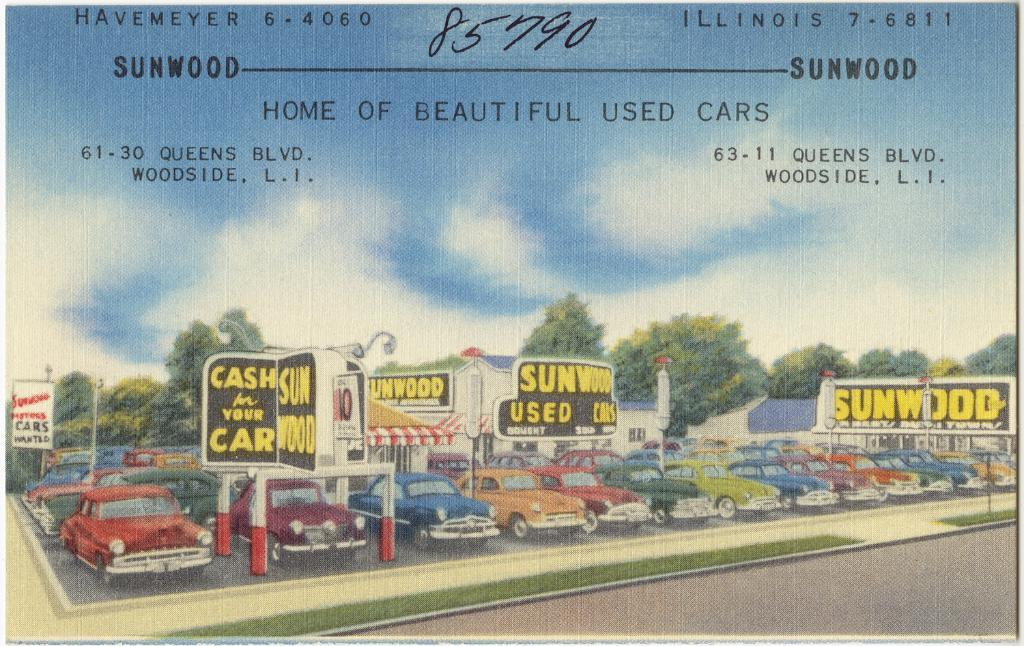What type of visual is the image? The image appears to be a poster. What vehicles are depicted on the poster? Cars are depicted on the poster. What structures are depicted on the poster? Poles, boards, and houses are depicted on the poster. What type of vegetation is depicted on the poster? Trees are depicted on the poster. What part of the natural environment is visible on the poster? The sky is visible on the poster. What type of text is present on the poster? There are words and numbers on the poster. How many cats are sleeping in the crib on the poster? There are no cats or cribs depicted on the poster; it features a variety of vehicles, structures, vegetation, and the sky. What type of currency is shown on the poster? There is no currency depicted on the poster; it features cars, poles, boards, houses, trees, the sky, and text. 